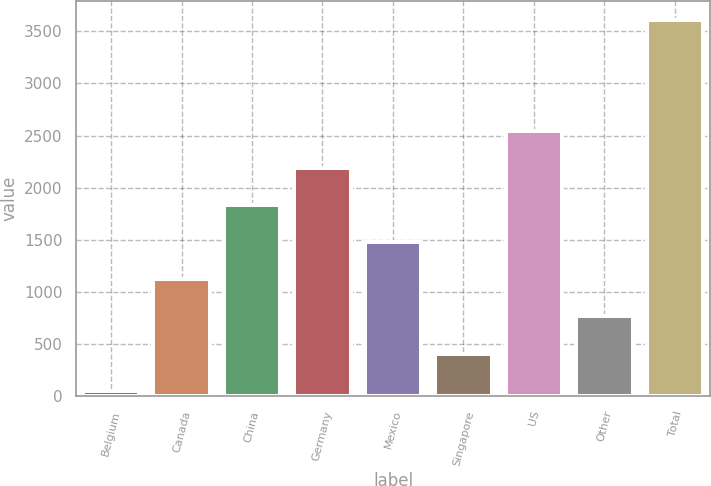<chart> <loc_0><loc_0><loc_500><loc_500><bar_chart><fcel>Belgium<fcel>Canada<fcel>China<fcel>Germany<fcel>Mexico<fcel>Singapore<fcel>US<fcel>Other<fcel>Total<nl><fcel>56<fcel>1121.9<fcel>1832.5<fcel>2187.8<fcel>1477.2<fcel>411.3<fcel>2543.1<fcel>766.6<fcel>3609<nl></chart> 